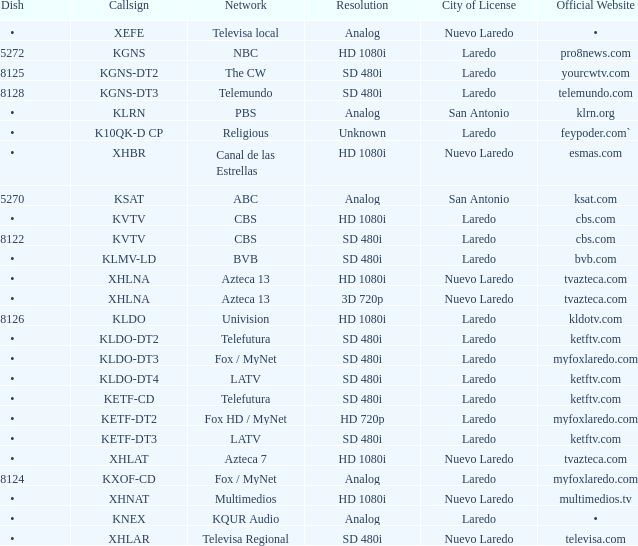Name the resolution with dish of 8126 HD 1080i. 